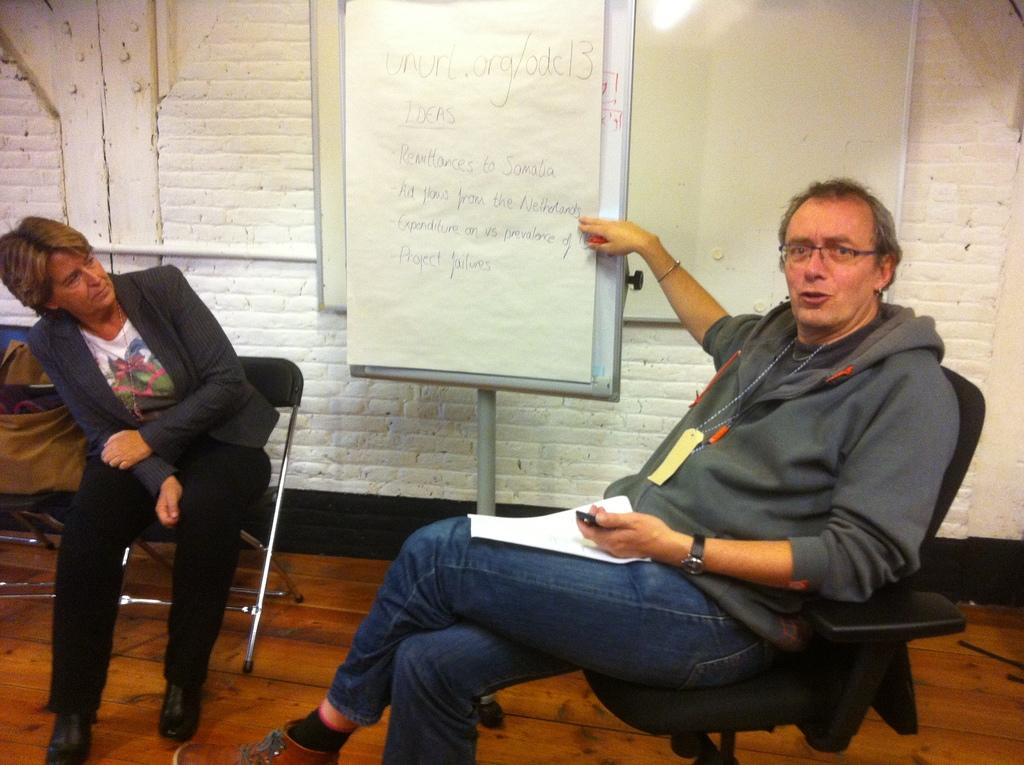What is the man in the image doing? The man is sitting in a chair and pointing at a board. What might the man be doing while pointing at the board? The man is explaining something. Who is sitting beside the man? There is a woman sitting beside the man. What is the woman doing in the image? The woman is sitting in another chair and looking at the board. How many pigs can be seen in the image? There are no pigs present in the image. What type of fork is the man using to explain the information on the board? There is no fork present in the image; the man is using his finger to point at the board. 